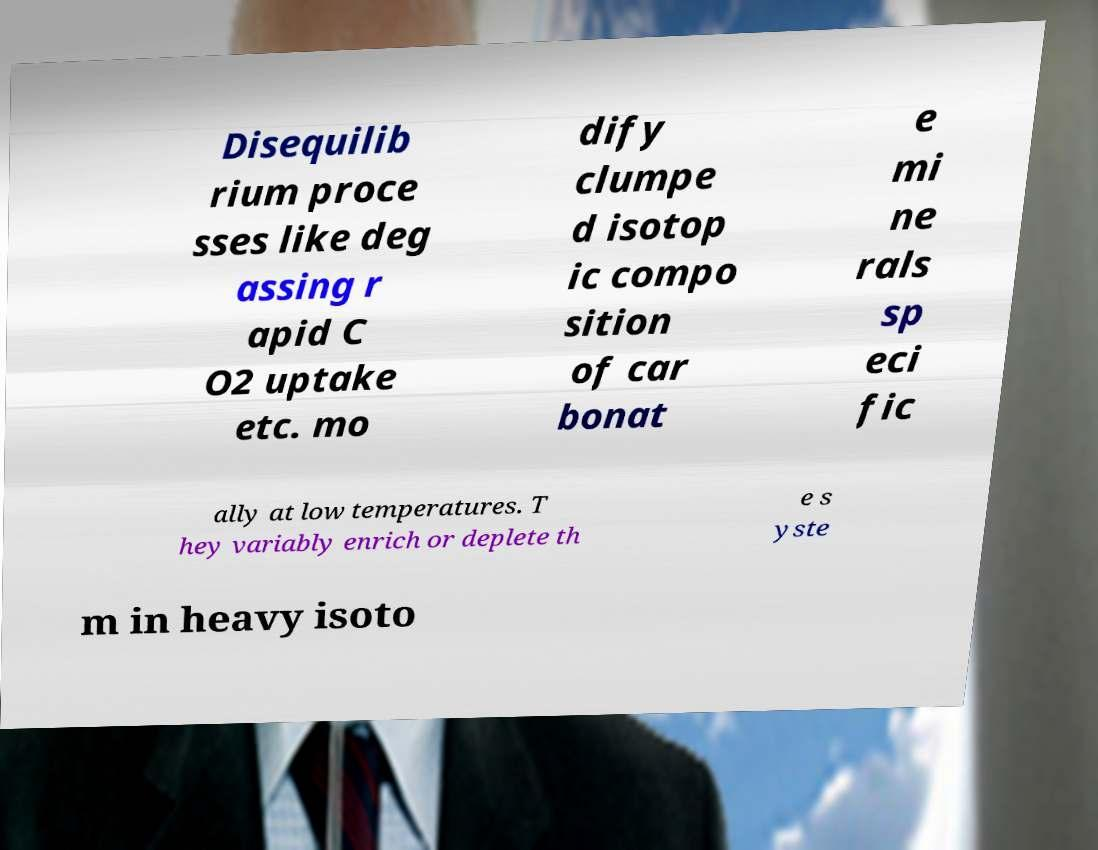Can you accurately transcribe the text from the provided image for me? Disequilib rium proce sses like deg assing r apid C O2 uptake etc. mo dify clumpe d isotop ic compo sition of car bonat e mi ne rals sp eci fic ally at low temperatures. T hey variably enrich or deplete th e s yste m in heavy isoto 